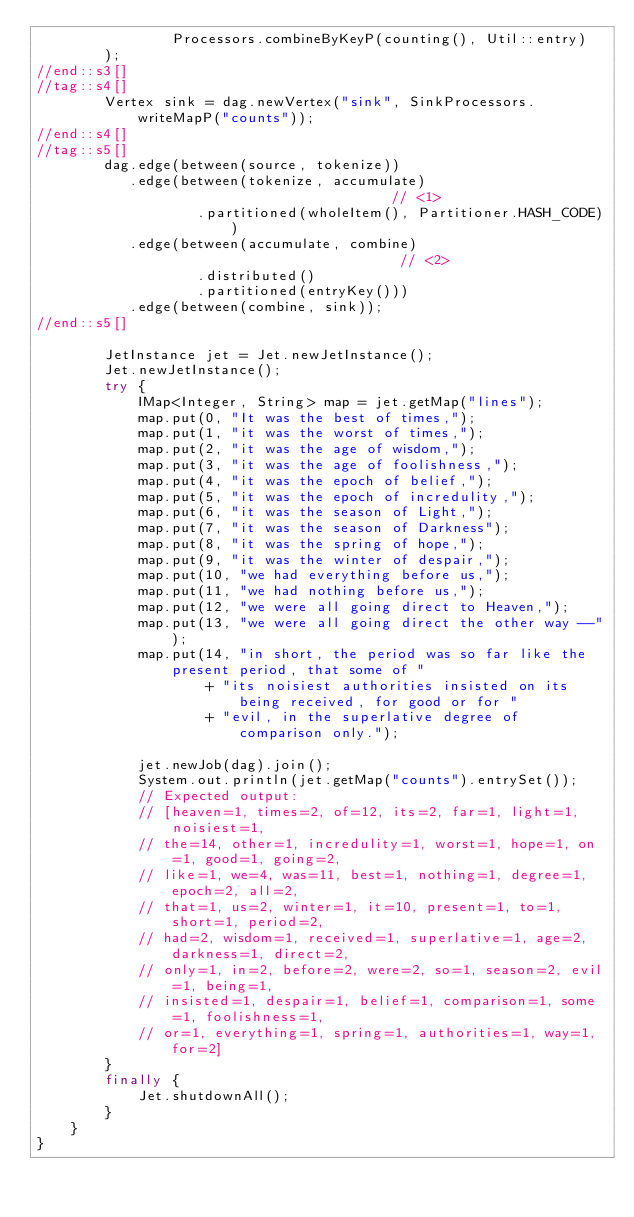<code> <loc_0><loc_0><loc_500><loc_500><_Java_>                Processors.combineByKeyP(counting(), Util::entry)
        );
//end::s3[]
//tag::s4[]
        Vertex sink = dag.newVertex("sink", SinkProcessors.writeMapP("counts"));
//end::s4[]
//tag::s5[]
        dag.edge(between(source, tokenize))
           .edge(between(tokenize, accumulate)                            // <1>
                   .partitioned(wholeItem(), Partitioner.HASH_CODE))
           .edge(between(accumulate, combine)                             // <2>
                   .distributed()
                   .partitioned(entryKey()))
           .edge(between(combine, sink));
//end::s5[]

        JetInstance jet = Jet.newJetInstance();
        Jet.newJetInstance();
        try {
            IMap<Integer, String> map = jet.getMap("lines");
            map.put(0, "It was the best of times,");
            map.put(1, "it was the worst of times,");
            map.put(2, "it was the age of wisdom,");
            map.put(3, "it was the age of foolishness,");
            map.put(4, "it was the epoch of belief,");
            map.put(5, "it was the epoch of incredulity,");
            map.put(6, "it was the season of Light,");
            map.put(7, "it was the season of Darkness");
            map.put(8, "it was the spring of hope,");
            map.put(9, "it was the winter of despair,");
            map.put(10, "we had everything before us,");
            map.put(11, "we had nothing before us,");
            map.put(12, "we were all going direct to Heaven,");
            map.put(13, "we were all going direct the other way --");
            map.put(14, "in short, the period was so far like the present period, that some of "
                    + "its noisiest authorities insisted on its being received, for good or for "
                    + "evil, in the superlative degree of comparison only.");

            jet.newJob(dag).join();
            System.out.println(jet.getMap("counts").entrySet());
            // Expected output:
            // [heaven=1, times=2, of=12, its=2, far=1, light=1, noisiest=1,
            // the=14, other=1, incredulity=1, worst=1, hope=1, on=1, good=1, going=2,
            // like=1, we=4, was=11, best=1, nothing=1, degree=1, epoch=2, all=2,
            // that=1, us=2, winter=1, it=10, present=1, to=1, short=1, period=2,
            // had=2, wisdom=1, received=1, superlative=1, age=2, darkness=1, direct=2,
            // only=1, in=2, before=2, were=2, so=1, season=2, evil=1, being=1,
            // insisted=1, despair=1, belief=1, comparison=1, some=1, foolishness=1,
            // or=1, everything=1, spring=1, authorities=1, way=1, for=2]
        }
        finally {
            Jet.shutdownAll();
        }
    }
}
</code> 